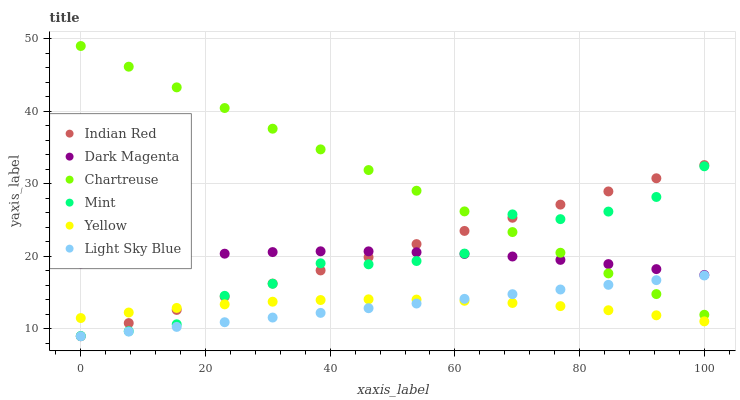Does Yellow have the minimum area under the curve?
Answer yes or no. Yes. Does Chartreuse have the maximum area under the curve?
Answer yes or no. Yes. Does Chartreuse have the minimum area under the curve?
Answer yes or no. No. Does Yellow have the maximum area under the curve?
Answer yes or no. No. Is Indian Red the smoothest?
Answer yes or no. Yes. Is Mint the roughest?
Answer yes or no. Yes. Is Yellow the smoothest?
Answer yes or no. No. Is Yellow the roughest?
Answer yes or no. No. Does Light Sky Blue have the lowest value?
Answer yes or no. Yes. Does Yellow have the lowest value?
Answer yes or no. No. Does Chartreuse have the highest value?
Answer yes or no. Yes. Does Yellow have the highest value?
Answer yes or no. No. Is Light Sky Blue less than Mint?
Answer yes or no. Yes. Is Mint greater than Light Sky Blue?
Answer yes or no. Yes. Does Chartreuse intersect Light Sky Blue?
Answer yes or no. Yes. Is Chartreuse less than Light Sky Blue?
Answer yes or no. No. Is Chartreuse greater than Light Sky Blue?
Answer yes or no. No. Does Light Sky Blue intersect Mint?
Answer yes or no. No. 